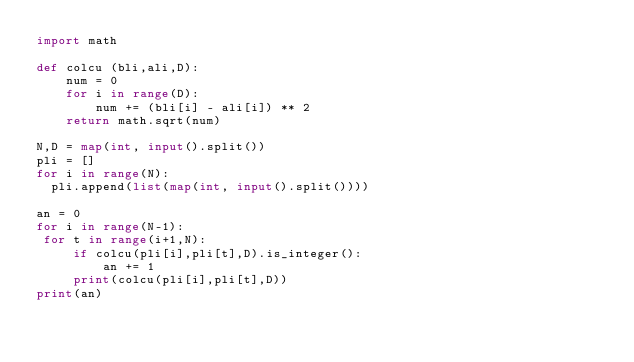<code> <loc_0><loc_0><loc_500><loc_500><_Python_>import math

def colcu (bli,ali,D):
    num = 0
    for i in range(D):
        num += (bli[i] - ali[i]) ** 2
    return math.sqrt(num)

N,D = map(int, input().split())
pli = []
for i in range(N):
  pli.append(list(map(int, input().split())))

an = 0
for i in range(N-1):
 for t in range(i+1,N):
     if colcu(pli[i],pli[t],D).is_integer():
         an += 1
     print(colcu(pli[i],pli[t],D))
print(an)</code> 